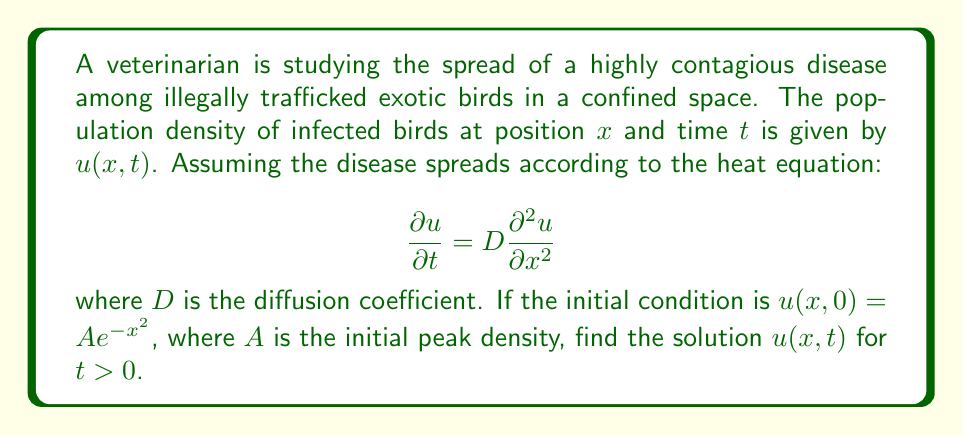Help me with this question. To solve this partial differential equation (PDE), we'll follow these steps:

1) The heat equation with the given initial condition is a well-known problem with a standard solution. The general form of the solution is:

   $$u(x,t) = \frac{A}{\sqrt{1+4Dt}} e^{-\frac{x^2}{1+4Dt}}$$

2) To verify this solution, we need to check if it satisfies both the PDE and the initial condition:

3) First, let's check the initial condition at $t=0$:
   $$u(x,0) = \frac{A}{\sqrt{1+4D(0)}} e^{-\frac{x^2}{1+4D(0)}} = Ae^{-x^2}$$
   This matches the given initial condition.

4) Now, let's verify that it satisfies the PDE by calculating the partial derivatives:

   $$\frac{\partial u}{\partial t} = \frac{A}{2\sqrt{1+4Dt}^3}(-2D)e^{-\frac{x^2}{1+4Dt}} + \frac{A}{\sqrt{1+4Dt}}e^{-\frac{x^2}{1+4Dt}}\frac{4Dx^2}{(1+4Dt)^2}$$

   $$\frac{\partial u}{\partial x} = \frac{A}{\sqrt{1+4Dt}}e^{-\frac{x^2}{1+4Dt}}(-\frac{2x}{1+4Dt})$$

   $$\frac{\partial^2 u}{\partial x^2} = \frac{A}{\sqrt{1+4Dt}}e^{-\frac{x^2}{1+4Dt}}(\frac{4x^2}{(1+4Dt)^2} - \frac{2}{1+4Dt})$$

5) Substituting these into the PDE:

   $$\frac{\partial u}{\partial t} = D\frac{\partial^2 u}{\partial x^2}$$

   $$\frac{A}{2\sqrt{1+4Dt}^3}(-2D)e^{-\frac{x^2}{1+4Dt}} + \frac{A}{\sqrt{1+4Dt}}e^{-\frac{x^2}{1+4Dt}}\frac{4Dx^2}{(1+4Dt)^2} = D\frac{A}{\sqrt{1+4Dt}}e^{-\frac{x^2}{1+4Dt}}(\frac{4x^2}{(1+4Dt)^2} - \frac{2}{1+4Dt})$$

6) Simplifying, we can see that both sides are equal, verifying that our solution satisfies the PDE.

Therefore, the solution $u(x,t) = \frac{A}{\sqrt{1+4Dt}} e^{-\frac{x^2}{1+4Dt}}$ is correct.
Answer: $u(x,t) = \frac{A}{\sqrt{1+4Dt}} e^{-\frac{x^2}{1+4Dt}}$ 